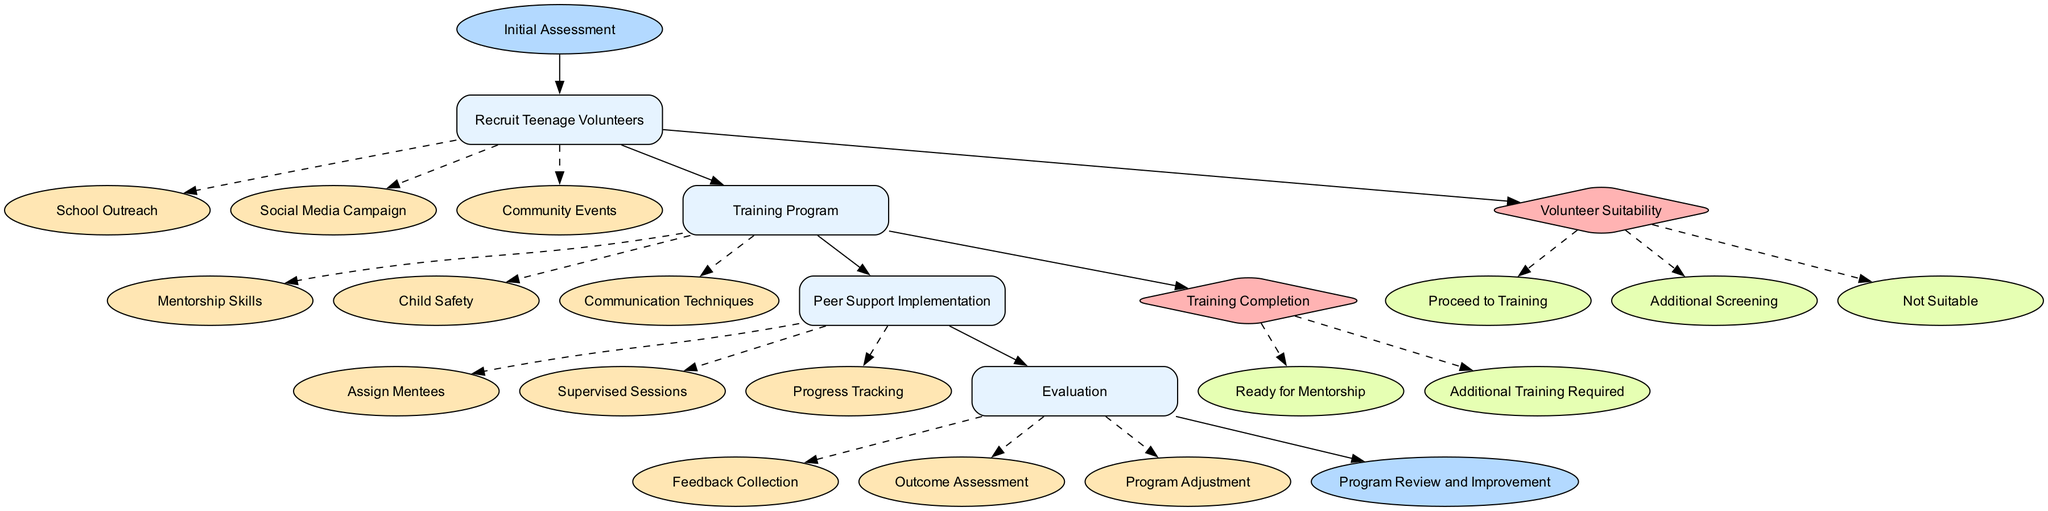What is the first step in the pathway? The first step in the pathway is labeled as "Initial Assessment," which is the starting point of the clinical pathway.
Answer: Initial Assessment How many actions are listed under the "Training Program" step? The "Training Program" step includes three actions: Mentorship Skills, Child Safety, and Communication Techniques. Therefore, the total count of actions is three.
Answer: 3 What are the available options in the "Volunteer Suitability" decision point? The "Volunteer Suitability" decision point has three options listed: Proceed to Training, Additional Screening, and Not Suitable.
Answer: Proceed to Training, Additional Screening, Not Suitable What action follows the "Evaluation" step? The "Evaluation" step leads directly to the end point of the pathway, which is referred to as "Program Review and Improvement." Thus, the action that follows is the conclusion of the pathway.
Answer: Program Review and Improvement How many steps are there in the clinical pathway? The diagram lists four steps: Recruit Teenage Volunteers, Training Program, Peer Support Implementation, and Evaluation. Counting these steps gives a total of four.
Answer: 4 If a volunteer is deemed "Not Suitable," what will happen next? If a volunteer is categorized as "Not Suitable," they will not proceed further in the pathway, indicating that they will be excluded from the subsequent steps.
Answer: Not proceed What is the last decision point in the pathway? The last decision point in the pathway is "Training Completion," as it follows the training and determines the next actions based on the completion status.
Answer: Training Completion Which step comes after "Recruit Teenage Volunteers"? The step that follows "Recruit Teenage Volunteers" is "Training Program," as the pathway progresses from recruitment to training preparation.
Answer: Training Program What is the purpose of the "Feedback Collection" action in the Evaluation step? The action "Feedback Collection" in the Evaluation step serves to gather opinions and experiences from participants to assess program effectiveness and areas for improvement.
Answer: Gather opinions and experiences 